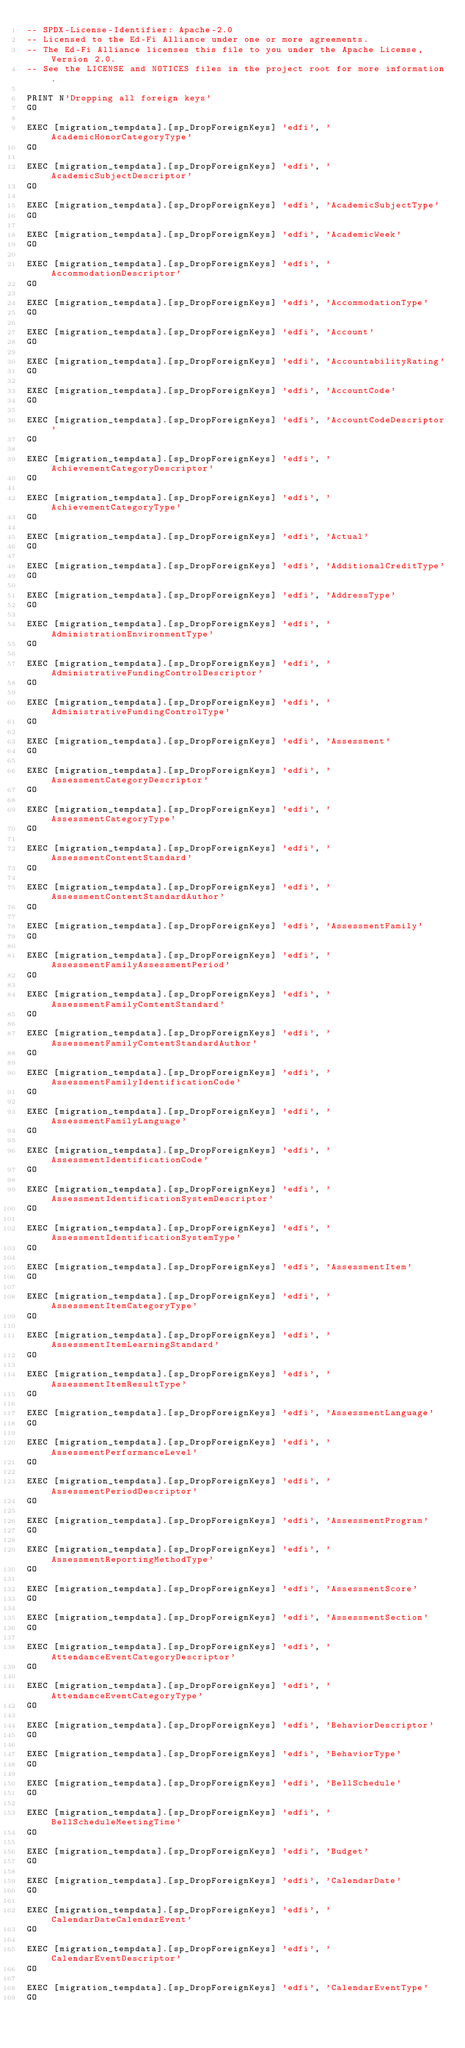<code> <loc_0><loc_0><loc_500><loc_500><_SQL_>-- SPDX-License-Identifier: Apache-2.0
-- Licensed to the Ed-Fi Alliance under one or more agreements.
-- The Ed-Fi Alliance licenses this file to you under the Apache License, Version 2.0.
-- See the LICENSE and NOTICES files in the project root for more information.

PRINT N'Dropping all foreign keys'
GO

EXEC [migration_tempdata].[sp_DropForeignKeys] 'edfi', 'AcademicHonorCategoryType'
GO

EXEC [migration_tempdata].[sp_DropForeignKeys] 'edfi', 'AcademicSubjectDescriptor'
GO

EXEC [migration_tempdata].[sp_DropForeignKeys] 'edfi', 'AcademicSubjectType'
GO

EXEC [migration_tempdata].[sp_DropForeignKeys] 'edfi', 'AcademicWeek'
GO

EXEC [migration_tempdata].[sp_DropForeignKeys] 'edfi', 'AccommodationDescriptor'
GO

EXEC [migration_tempdata].[sp_DropForeignKeys] 'edfi', 'AccommodationType'
GO

EXEC [migration_tempdata].[sp_DropForeignKeys] 'edfi', 'Account'
GO

EXEC [migration_tempdata].[sp_DropForeignKeys] 'edfi', 'AccountabilityRating'
GO

EXEC [migration_tempdata].[sp_DropForeignKeys] 'edfi', 'AccountCode'
GO

EXEC [migration_tempdata].[sp_DropForeignKeys] 'edfi', 'AccountCodeDescriptor'
GO

EXEC [migration_tempdata].[sp_DropForeignKeys] 'edfi', 'AchievementCategoryDescriptor'
GO

EXEC [migration_tempdata].[sp_DropForeignKeys] 'edfi', 'AchievementCategoryType'
GO

EXEC [migration_tempdata].[sp_DropForeignKeys] 'edfi', 'Actual'
GO

EXEC [migration_tempdata].[sp_DropForeignKeys] 'edfi', 'AdditionalCreditType'
GO

EXEC [migration_tempdata].[sp_DropForeignKeys] 'edfi', 'AddressType'
GO

EXEC [migration_tempdata].[sp_DropForeignKeys] 'edfi', 'AdministrationEnvironmentType'
GO

EXEC [migration_tempdata].[sp_DropForeignKeys] 'edfi', 'AdministrativeFundingControlDescriptor'
GO

EXEC [migration_tempdata].[sp_DropForeignKeys] 'edfi', 'AdministrativeFundingControlType'
GO

EXEC [migration_tempdata].[sp_DropForeignKeys] 'edfi', 'Assessment'
GO

EXEC [migration_tempdata].[sp_DropForeignKeys] 'edfi', 'AssessmentCategoryDescriptor'
GO

EXEC [migration_tempdata].[sp_DropForeignKeys] 'edfi', 'AssessmentCategoryType'
GO

EXEC [migration_tempdata].[sp_DropForeignKeys] 'edfi', 'AssessmentContentStandard'
GO

EXEC [migration_tempdata].[sp_DropForeignKeys] 'edfi', 'AssessmentContentStandardAuthor'
GO

EXEC [migration_tempdata].[sp_DropForeignKeys] 'edfi', 'AssessmentFamily'
GO

EXEC [migration_tempdata].[sp_DropForeignKeys] 'edfi', 'AssessmentFamilyAssessmentPeriod'
GO

EXEC [migration_tempdata].[sp_DropForeignKeys] 'edfi', 'AssessmentFamilyContentStandard'
GO

EXEC [migration_tempdata].[sp_DropForeignKeys] 'edfi', 'AssessmentFamilyContentStandardAuthor'
GO

EXEC [migration_tempdata].[sp_DropForeignKeys] 'edfi', 'AssessmentFamilyIdentificationCode'
GO

EXEC [migration_tempdata].[sp_DropForeignKeys] 'edfi', 'AssessmentFamilyLanguage'
GO

EXEC [migration_tempdata].[sp_DropForeignKeys] 'edfi', 'AssessmentIdentificationCode'
GO

EXEC [migration_tempdata].[sp_DropForeignKeys] 'edfi', 'AssessmentIdentificationSystemDescriptor'
GO

EXEC [migration_tempdata].[sp_DropForeignKeys] 'edfi', 'AssessmentIdentificationSystemType'
GO

EXEC [migration_tempdata].[sp_DropForeignKeys] 'edfi', 'AssessmentItem'
GO

EXEC [migration_tempdata].[sp_DropForeignKeys] 'edfi', 'AssessmentItemCategoryType'
GO

EXEC [migration_tempdata].[sp_DropForeignKeys] 'edfi', 'AssessmentItemLearningStandard'
GO

EXEC [migration_tempdata].[sp_DropForeignKeys] 'edfi', 'AssessmentItemResultType'
GO

EXEC [migration_tempdata].[sp_DropForeignKeys] 'edfi', 'AssessmentLanguage'
GO

EXEC [migration_tempdata].[sp_DropForeignKeys] 'edfi', 'AssessmentPerformanceLevel'
GO

EXEC [migration_tempdata].[sp_DropForeignKeys] 'edfi', 'AssessmentPeriodDescriptor'
GO

EXEC [migration_tempdata].[sp_DropForeignKeys] 'edfi', 'AssessmentProgram'
GO

EXEC [migration_tempdata].[sp_DropForeignKeys] 'edfi', 'AssessmentReportingMethodType'
GO

EXEC [migration_tempdata].[sp_DropForeignKeys] 'edfi', 'AssessmentScore'
GO

EXEC [migration_tempdata].[sp_DropForeignKeys] 'edfi', 'AssessmentSection'
GO

EXEC [migration_tempdata].[sp_DropForeignKeys] 'edfi', 'AttendanceEventCategoryDescriptor'
GO

EXEC [migration_tempdata].[sp_DropForeignKeys] 'edfi', 'AttendanceEventCategoryType'
GO

EXEC [migration_tempdata].[sp_DropForeignKeys] 'edfi', 'BehaviorDescriptor'
GO

EXEC [migration_tempdata].[sp_DropForeignKeys] 'edfi', 'BehaviorType'
GO

EXEC [migration_tempdata].[sp_DropForeignKeys] 'edfi', 'BellSchedule'
GO

EXEC [migration_tempdata].[sp_DropForeignKeys] 'edfi', 'BellScheduleMeetingTime'
GO

EXEC [migration_tempdata].[sp_DropForeignKeys] 'edfi', 'Budget'
GO

EXEC [migration_tempdata].[sp_DropForeignKeys] 'edfi', 'CalendarDate'
GO

EXEC [migration_tempdata].[sp_DropForeignKeys] 'edfi', 'CalendarDateCalendarEvent'
GO

EXEC [migration_tempdata].[sp_DropForeignKeys] 'edfi', 'CalendarEventDescriptor'
GO

EXEC [migration_tempdata].[sp_DropForeignKeys] 'edfi', 'CalendarEventType'
GO
</code> 